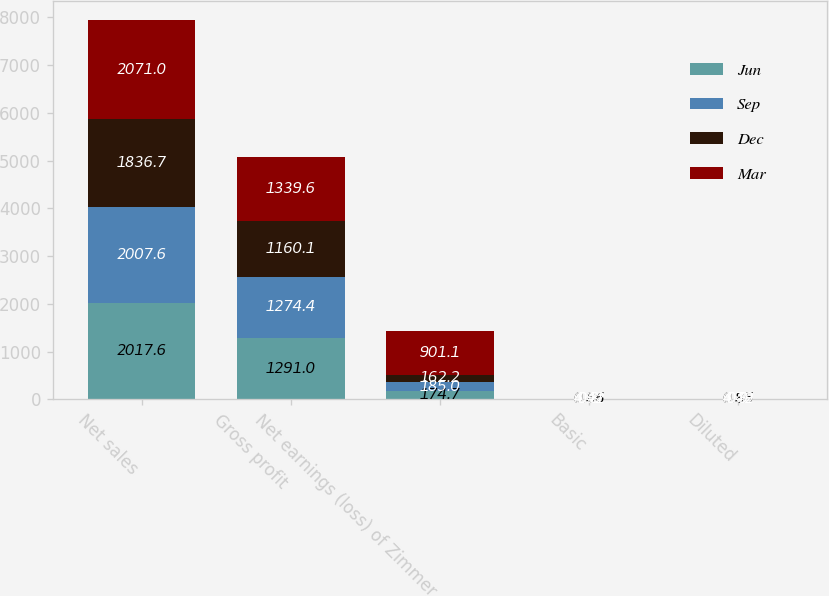<chart> <loc_0><loc_0><loc_500><loc_500><stacked_bar_chart><ecel><fcel>Net sales<fcel>Gross profit<fcel>Net earnings (loss) of Zimmer<fcel>Basic<fcel>Diluted<nl><fcel>Jun<fcel>2017.6<fcel>1291<fcel>174.7<fcel>0.86<fcel>0.85<nl><fcel>Sep<fcel>2007.6<fcel>1274.4<fcel>185<fcel>0.91<fcel>0.9<nl><fcel>Dec<fcel>1836.7<fcel>1160.1<fcel>162.2<fcel>0.8<fcel>0.79<nl><fcel>Mar<fcel>2071<fcel>1339.6<fcel>901.1<fcel>4.42<fcel>4.42<nl></chart> 